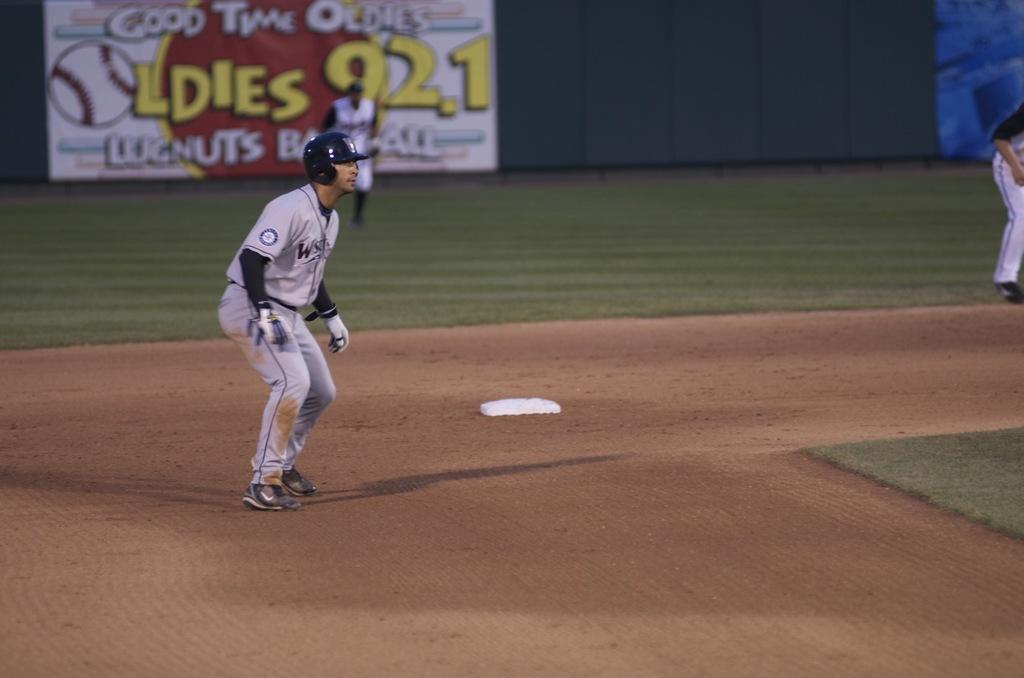<image>
Create a compact narrative representing the image presented. The sign on the outfield wall advertises for an oldies radio station. 